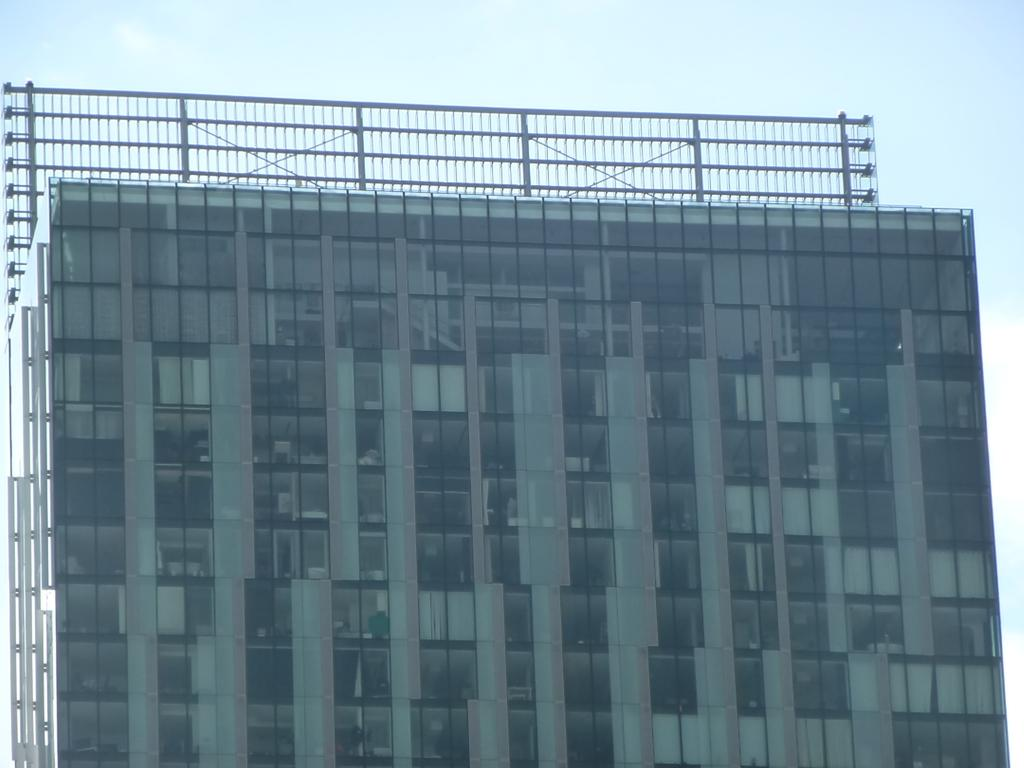Where was the image taken? The image was taken outdoors. What can be seen in the sky in the image? There is a sky with clouds visible in the image. What type of structure is present in the image? There is a building in the image. Can you describe the building's features? The building has walls, windows, doors, roofs, and grills. How many clocks are hanging on the walls of the building in the image? There is no mention of clocks in the image, so we cannot determine the number of clocks present. Is there a church visible in the image? No, there is no church visible in the image; it features a building with various features. 